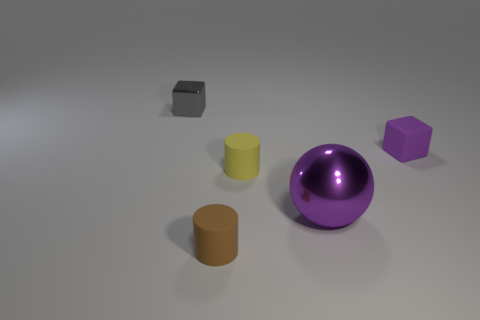Add 5 tiny blue matte balls. How many objects exist? 10 Subtract all spheres. How many objects are left? 4 Add 2 big blue matte spheres. How many big blue matte spheres exist? 2 Subtract 0 brown spheres. How many objects are left? 5 Subtract all big brown balls. Subtract all tiny yellow objects. How many objects are left? 4 Add 2 yellow rubber cylinders. How many yellow rubber cylinders are left? 3 